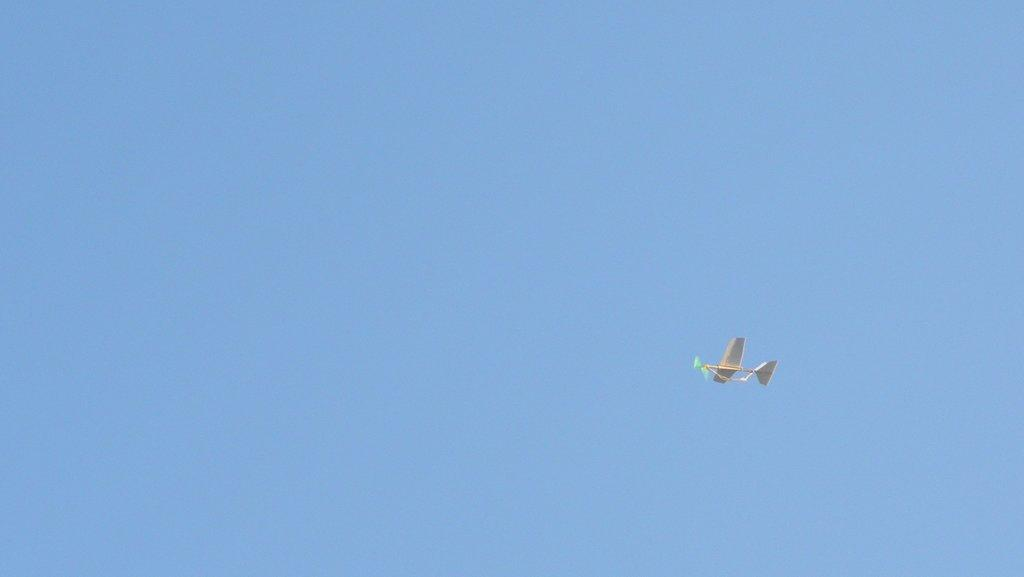Where was the image taken? The image is taken outdoors. What can be seen in the background of the image? There is the sky visible in the background. What is happening in the sky in the image? An airplane is flying in the sky. What type of hat is the ice wearing in the image? There is no ice or hat present in the image. What is the airplane teaching the students in the image? The image does not depict an airplane teaching students; it simply shows an airplane flying in the sky. 